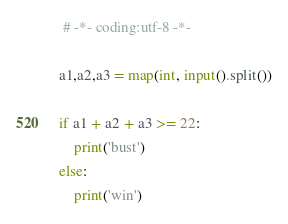<code> <loc_0><loc_0><loc_500><loc_500><_Python_> # -*- coding:utf-8 -*-

a1,a2,a3 = map(int, input().split())

if a1 + a2 + a3 >= 22:
    print('bust')
else:
    print('win')
</code> 